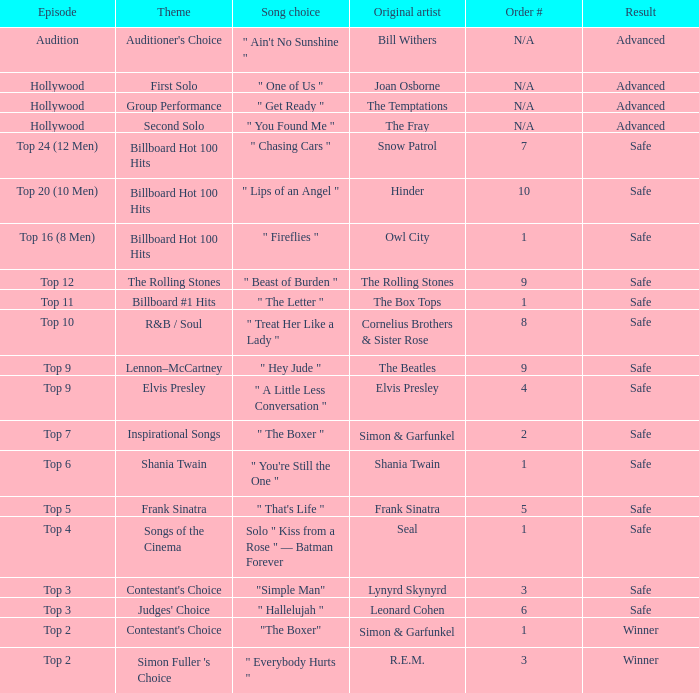What are the themes present in the top 16 (8 men) episode? Billboard Hot 100 Hits. 